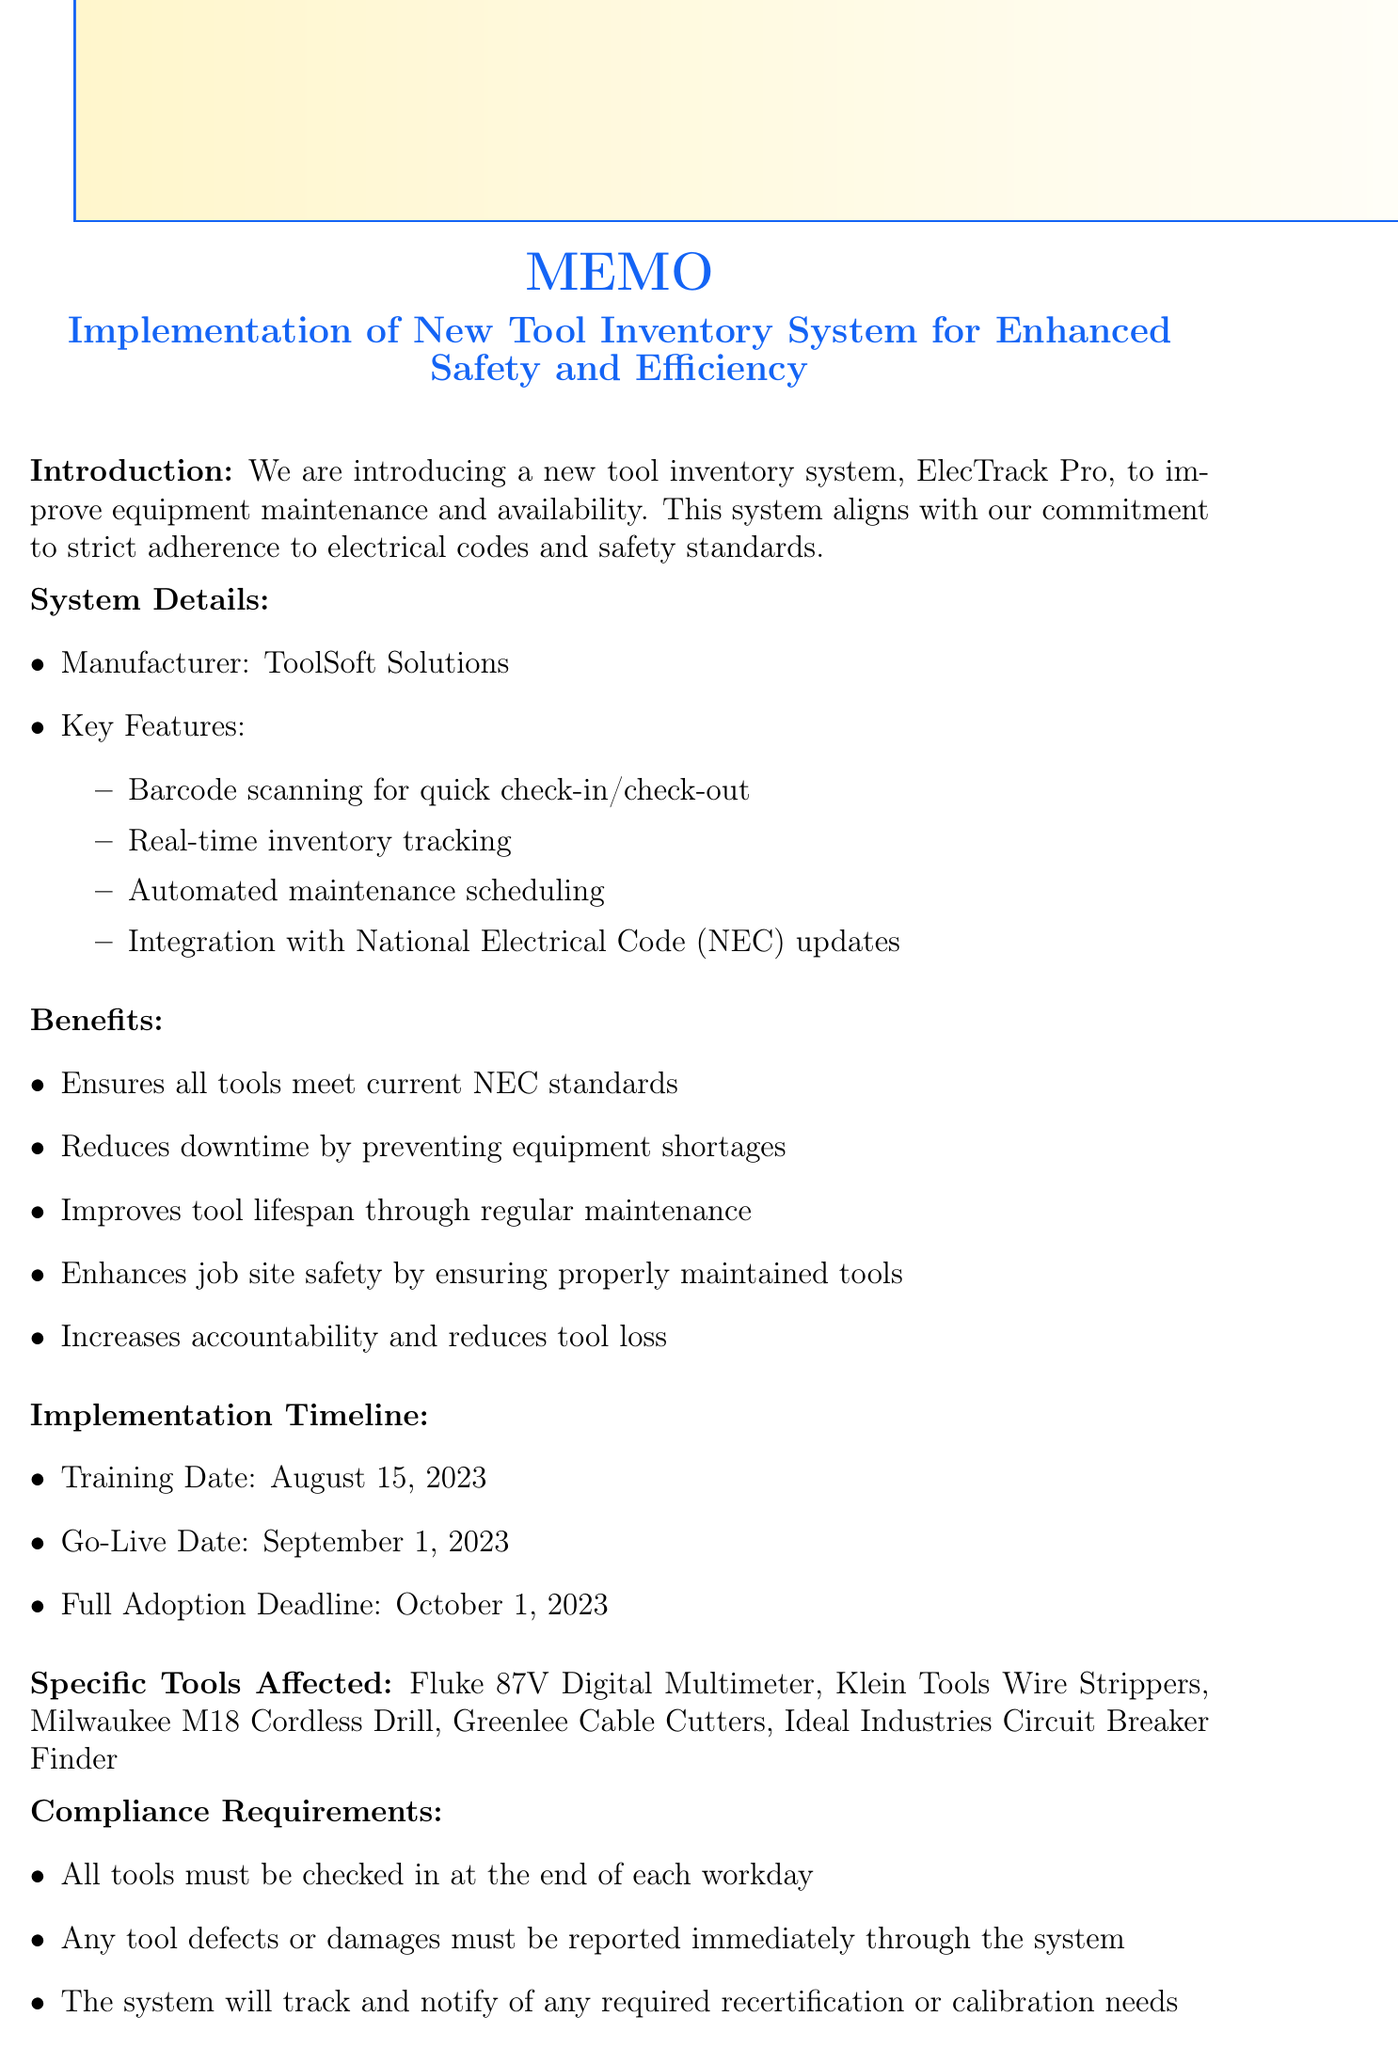What is the title of the memo? The title of the memo is the first line introduced in the document, which is about a new tool inventory system.
Answer: Implementation of New Tool Inventory System for Enhanced Safety and Efficiency Who is the manufacturer of the new system? The manufacturer is named in the system details section of the memo.
Answer: ToolSoft Solutions What is the key feature related to equipment tracking? The key feature that relates specifically to tracking tools is mentioned in the list of features under system details.
Answer: Real-time inventory tracking When is the full adoption deadline of the new system? The memo outlines an important date in the implementation timeline for full adoption of the system.
Answer: October 1, 2023 What tool must be checked in at the end of each workday? The compliance requirement specifies a general rule that applies to all tools to be checked in daily.
Answer: All tools Which feature ensures tools meet current NEC standards? One of the listed benefits of the new system directly addresses compliance with NEC standards.
Answer: Ensures all tools meet current NEC standards Who should be contacted for issues regarding the system? The contact information section provides a name for support related to the new system.
Answer: John Sparks Which tool is NOT listed among the specific tools affected? The memo provides a specific list of tools, and reasoning requires identifying which one is missing from that list.
Answer: (Depends on knowledge of potential tools, e.g., Any specific tool not mentioned, e.g., “Wrenches” if not included in the document.) 